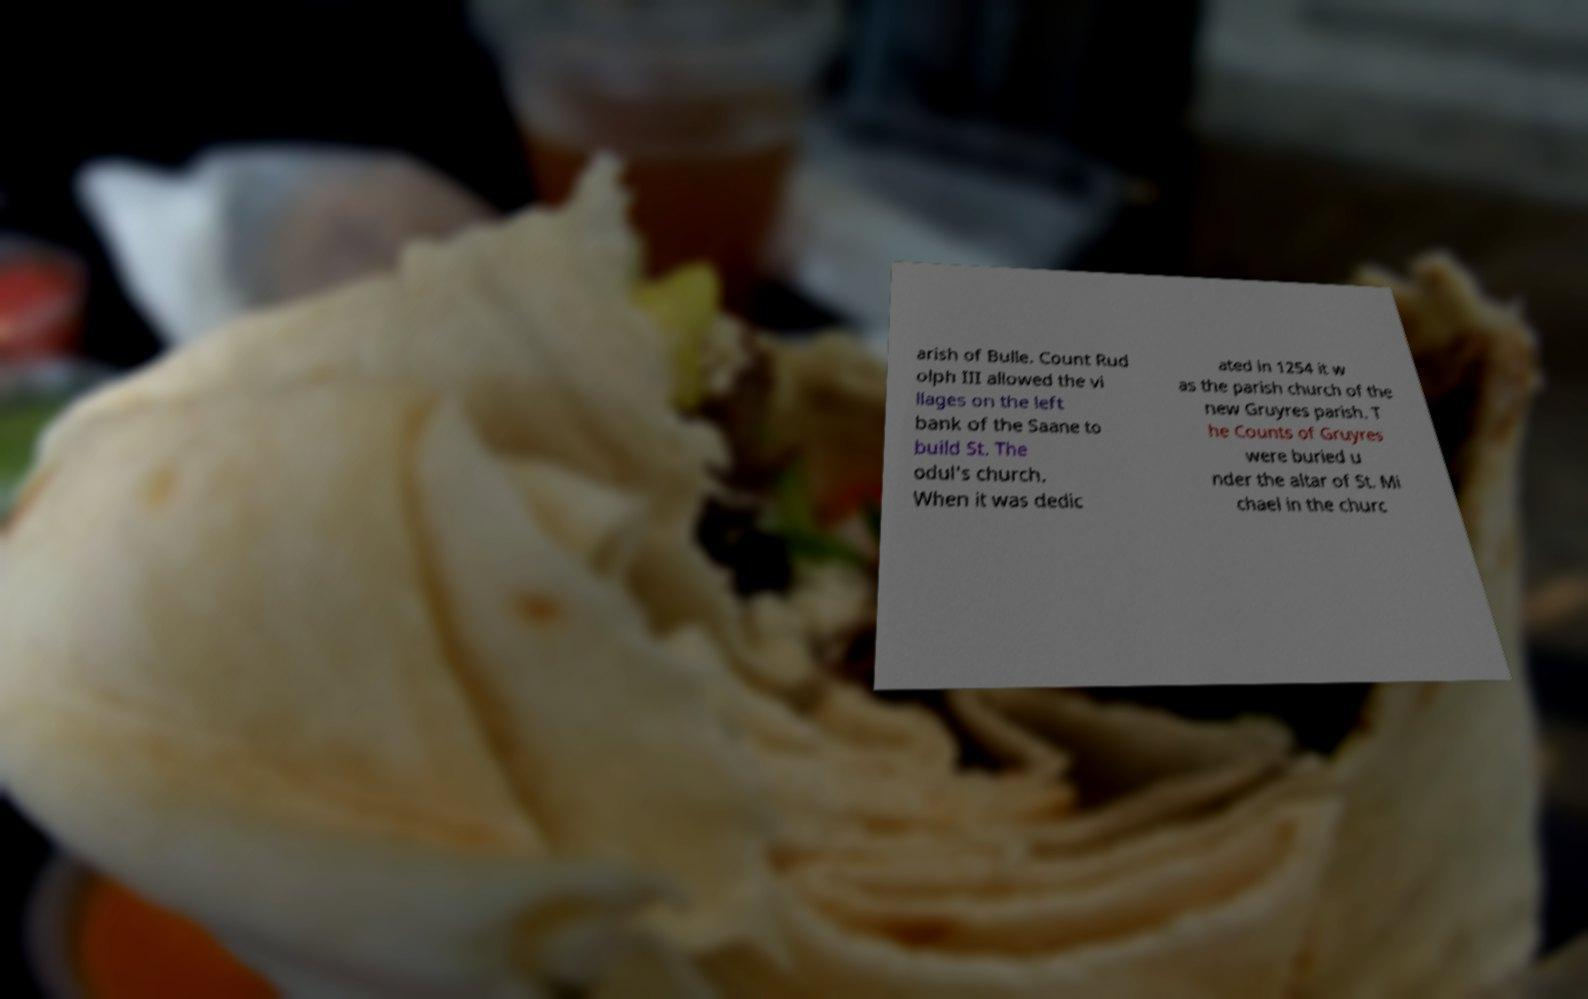There's text embedded in this image that I need extracted. Can you transcribe it verbatim? arish of Bulle. Count Rud olph III allowed the vi llages on the left bank of the Saane to build St. The odul's church. When it was dedic ated in 1254 it w as the parish church of the new Gruyres parish. T he Counts of Gruyres were buried u nder the altar of St. Mi chael in the churc 